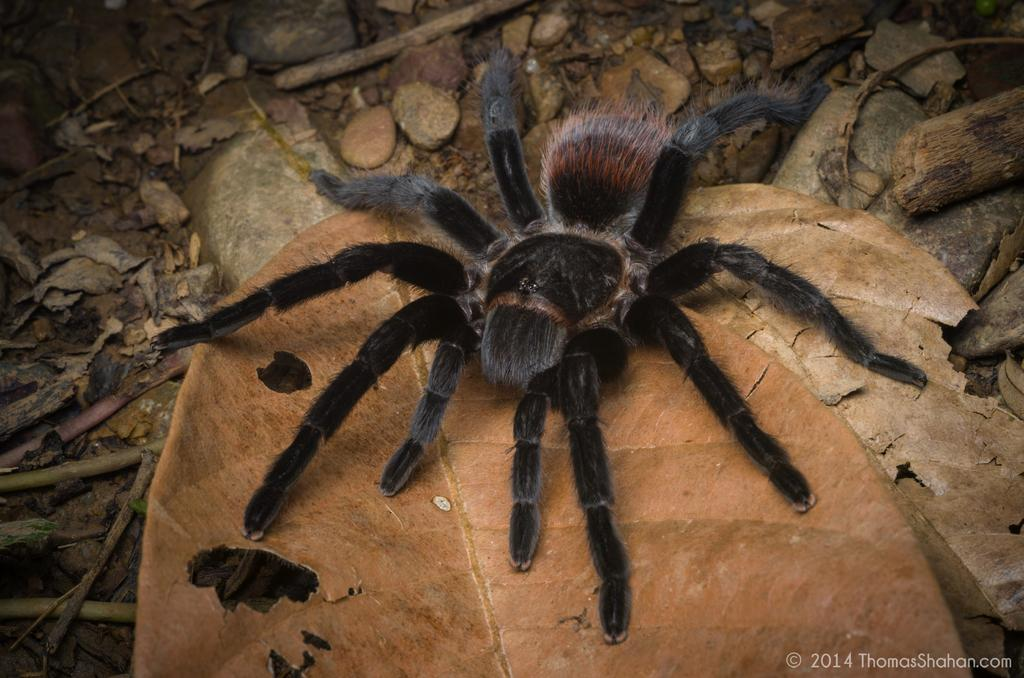What is the main subject of the image? There is a black spider in the image. Where is the spider located? The spider is on a dry leaf. What can be seen at the bottom of the image? There are stones at the bottom of the image. What other objects are present in the image? There are small wooden sticks in the image. What type of bird can be seen flying in the image? There is no bird present in the image; it features a black spider on a dry leaf, stones, and small wooden sticks. 